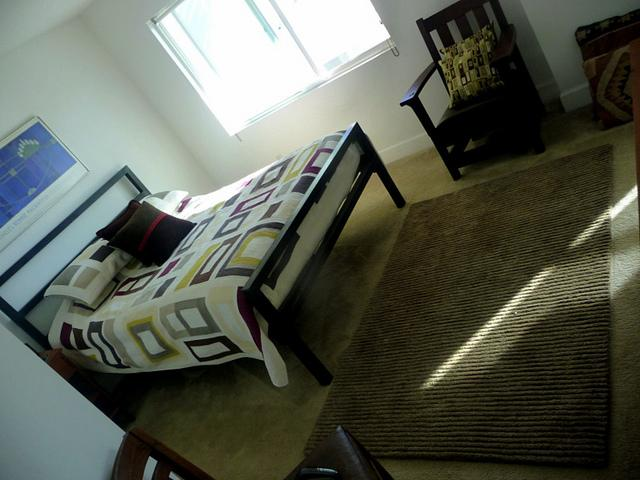What color is the painting on the wall behind the bed stand?

Choices:
A) red
B) yellow
C) green
D) blue blue 